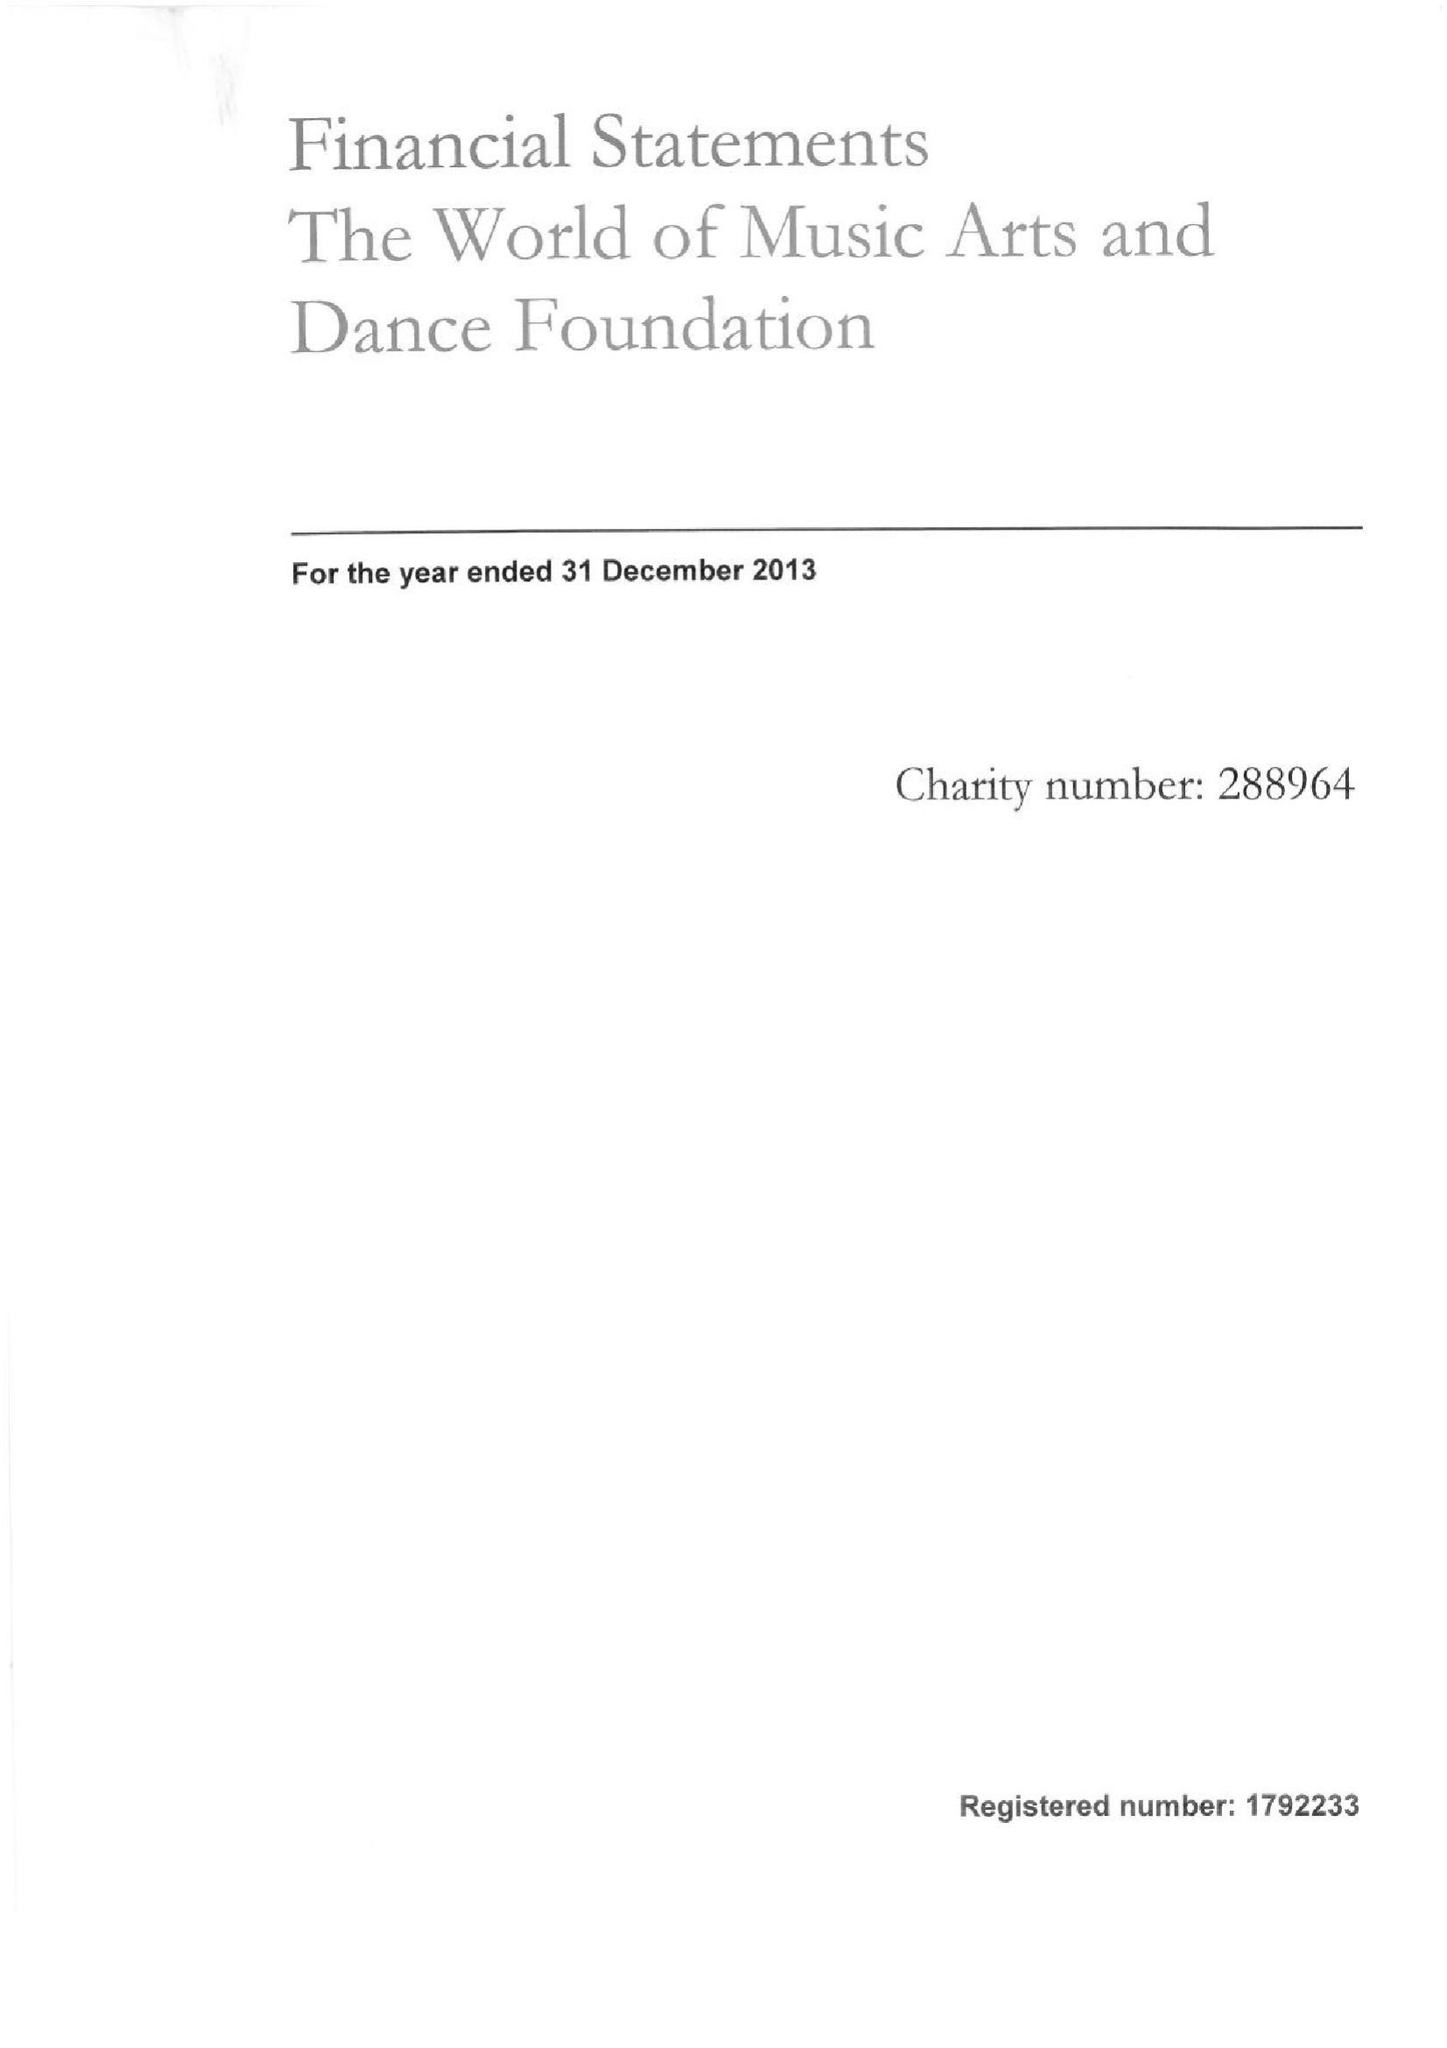What is the value for the charity_number?
Answer the question using a single word or phrase. 288964 